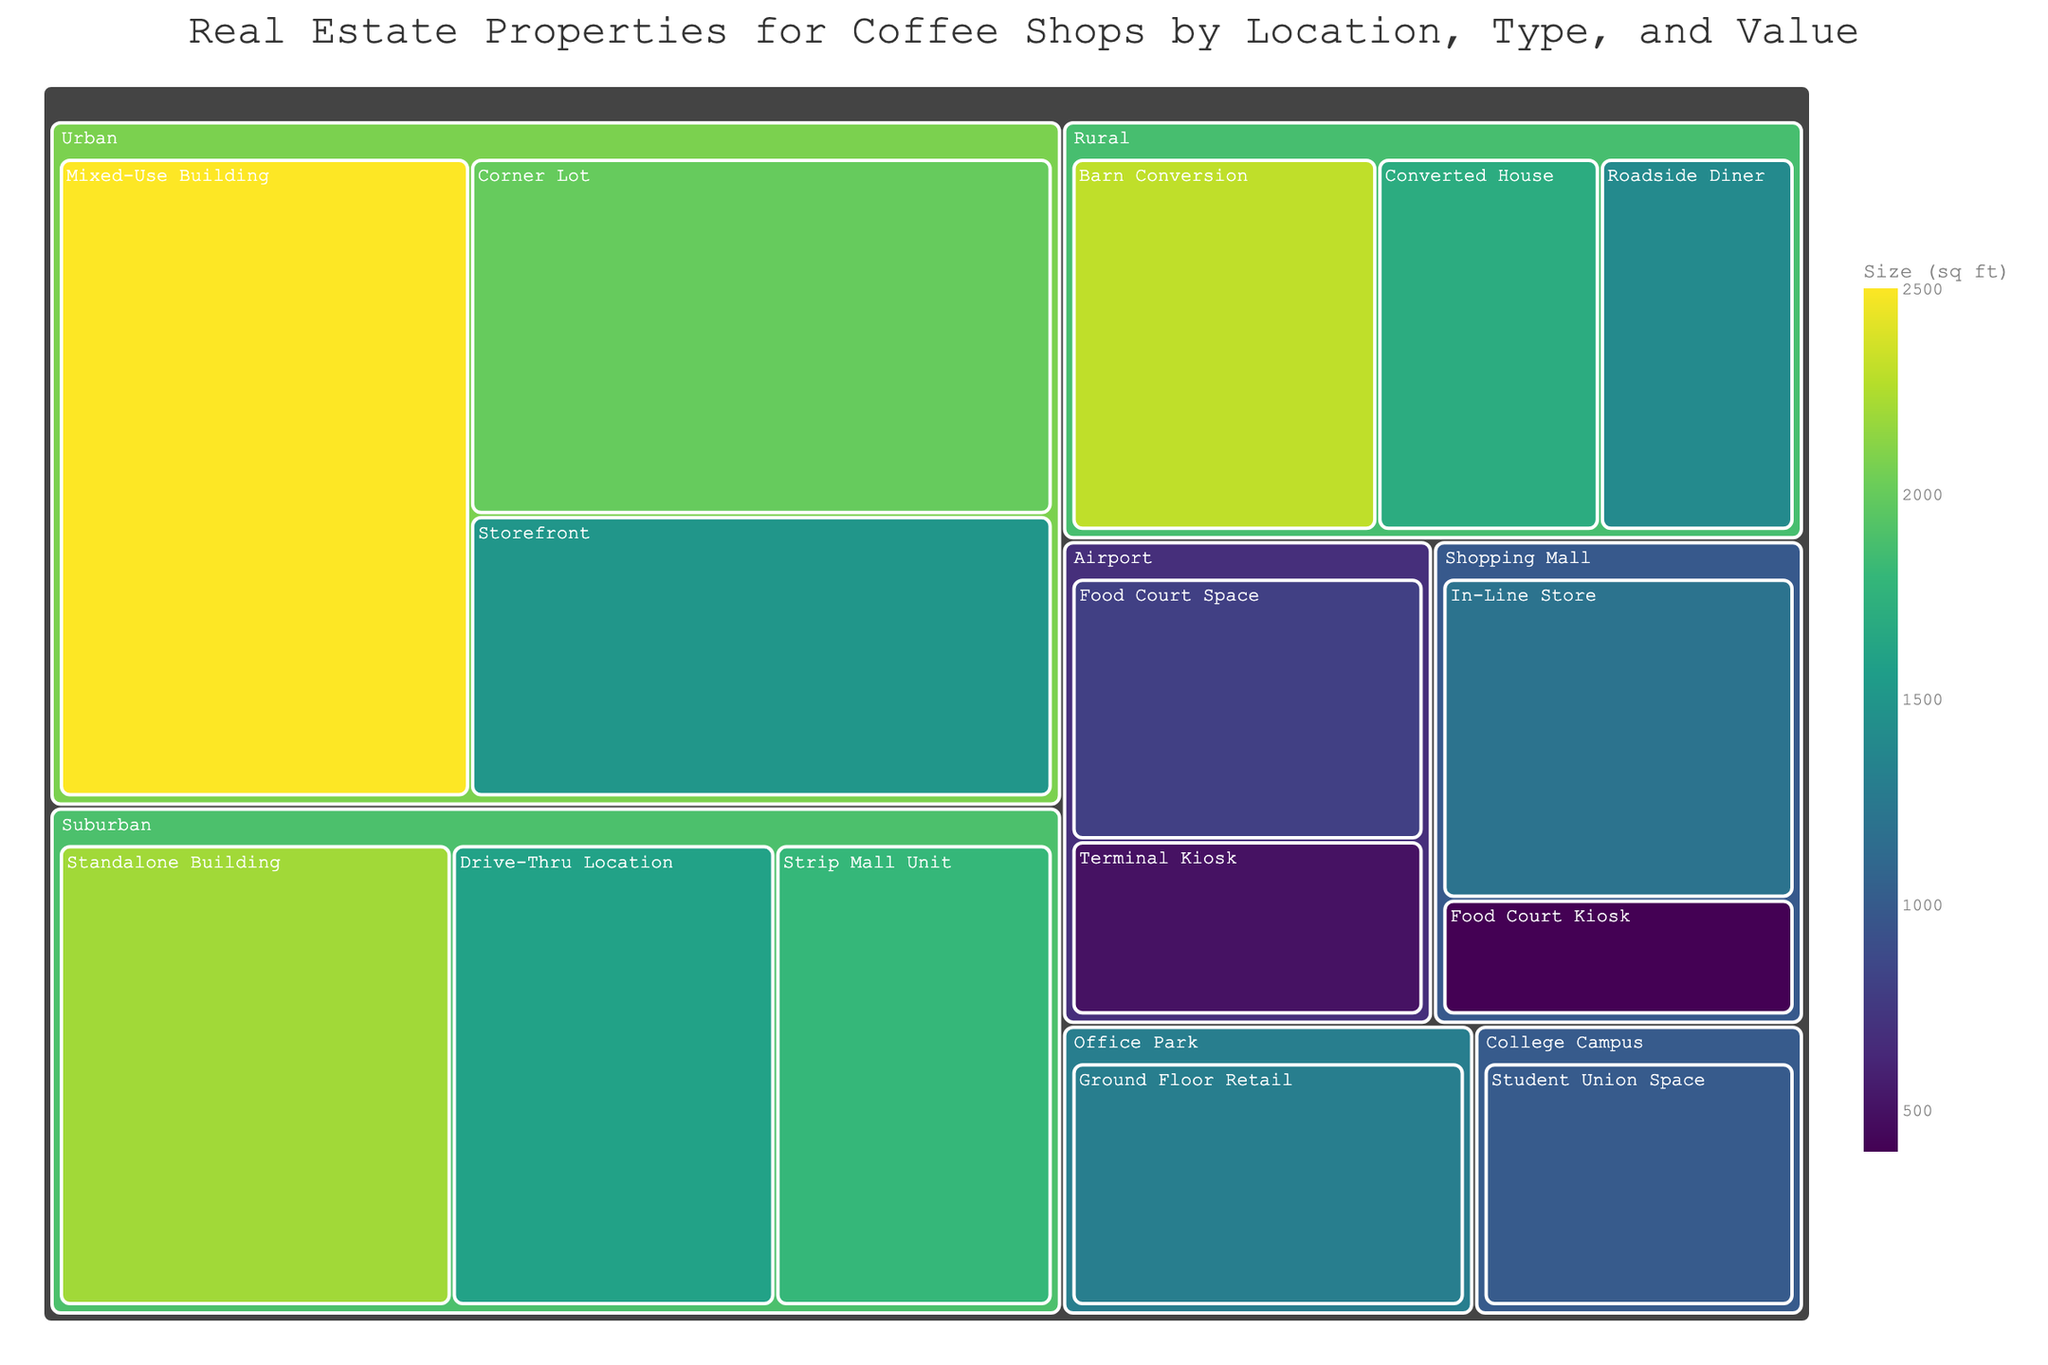What is the title of the treemap? The title of the treemap is typically displayed prominently at the top of the figure and provides an overview of what the data represents.
Answer: Real Estate Properties for Coffee Shops by Location, Type, and Value Which location has the highest value property type? To determine this, look for the box with the largest area within each location. The area size in a treemap reflects the value of the property.
Answer: Urban (Mixed-Use Building) What is the smallest property type at the Airport location based on size? Each location is broken down into its various property types, and "Size (sq ft)" is indicated by the color scale. Look for the property with the lightest color, which corresponds to the smallest size within the Airport location.
Answer: Terminal Kiosk What is the combined value of all properties in the Rural location? Sum the values of all the properties listed under the Rural location.
Answer: $1,300,000 Comparing Urban and Suburban locations, which has the higher average property value? Find the average value for all properties in both Urban and Suburban locations and compare them.
Answer: Urban Which property type has the largest size in the Suburban location? Check the color intensity within the Suburban location boxes; the darkest color represents the largest size.
Answer: Standalone Building How many property types are listed in the Shopping Mall location? Count the number of distinct Property Type names under the Shopping Mall location in the treemap.
Answer: 2 Which property type in the Urban location has a size of 2000 sq ft? Look for the darker shaded boxes in the Urban location until you find the one labeled with 2000 sq ft.
Answer: Corner Lot Between College Campus and Office Park locations, which has the lower valued property type? Compare the value figures of the property types in these two locations and find the lower one.
Answer: College Campus What is the value difference between the highest and lowest valued properties across all locations? Identify the highest and lowest values from the treemap and subtract the lowest from the highest.
Answer: $1,000,000 